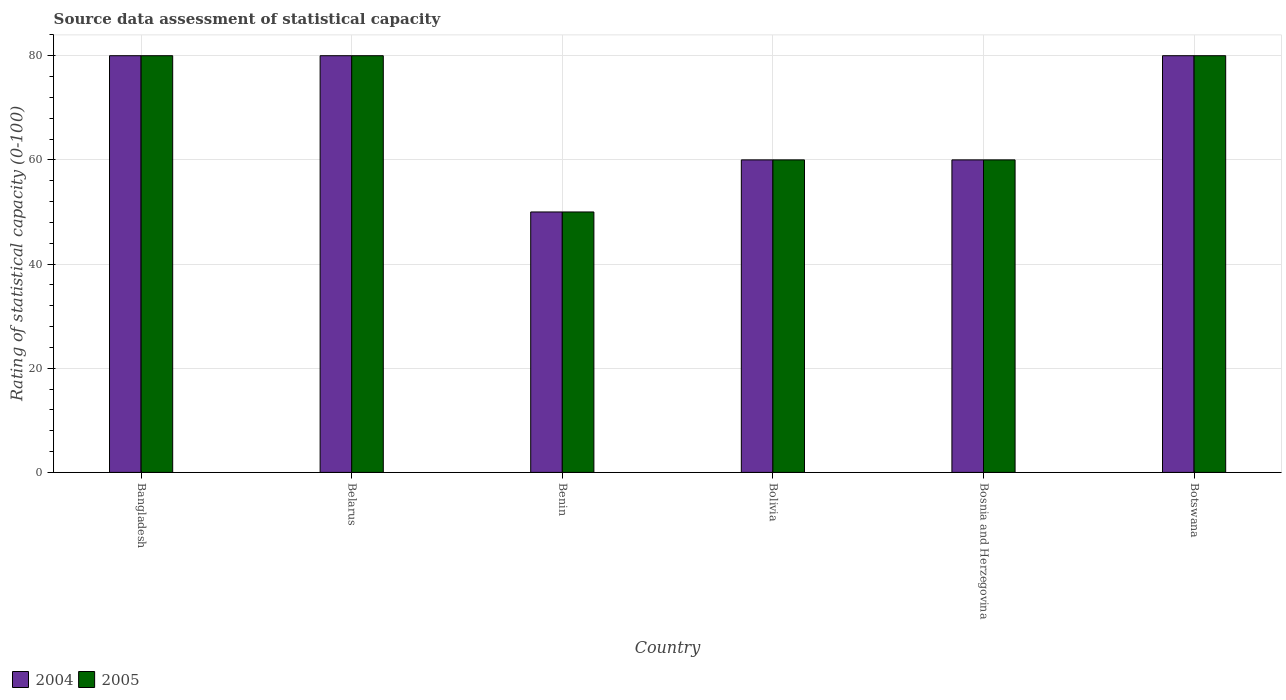How many bars are there on the 1st tick from the right?
Provide a short and direct response. 2. What is the label of the 5th group of bars from the left?
Make the answer very short. Bosnia and Herzegovina. Across all countries, what is the maximum rating of statistical capacity in 2004?
Your answer should be very brief. 80. Across all countries, what is the minimum rating of statistical capacity in 2004?
Keep it short and to the point. 50. In which country was the rating of statistical capacity in 2004 maximum?
Provide a short and direct response. Bangladesh. In which country was the rating of statistical capacity in 2005 minimum?
Offer a very short reply. Benin. What is the total rating of statistical capacity in 2005 in the graph?
Offer a very short reply. 410. What is the average rating of statistical capacity in 2005 per country?
Offer a very short reply. 68.33. What is the ratio of the rating of statistical capacity in 2005 in Bangladesh to that in Bosnia and Herzegovina?
Keep it short and to the point. 1.33. Is the difference between the rating of statistical capacity in 2005 in Benin and Botswana greater than the difference between the rating of statistical capacity in 2004 in Benin and Botswana?
Offer a terse response. No. What is the difference between the highest and the lowest rating of statistical capacity in 2004?
Provide a succinct answer. 30. In how many countries, is the rating of statistical capacity in 2004 greater than the average rating of statistical capacity in 2004 taken over all countries?
Ensure brevity in your answer.  3. Is the sum of the rating of statistical capacity in 2005 in Bangladesh and Benin greater than the maximum rating of statistical capacity in 2004 across all countries?
Offer a terse response. Yes. Are all the bars in the graph horizontal?
Offer a terse response. No. What is the difference between two consecutive major ticks on the Y-axis?
Give a very brief answer. 20. Are the values on the major ticks of Y-axis written in scientific E-notation?
Keep it short and to the point. No. Does the graph contain grids?
Ensure brevity in your answer.  Yes. How many legend labels are there?
Offer a very short reply. 2. What is the title of the graph?
Give a very brief answer. Source data assessment of statistical capacity. Does "2013" appear as one of the legend labels in the graph?
Make the answer very short. No. What is the label or title of the Y-axis?
Give a very brief answer. Rating of statistical capacity (0-100). What is the Rating of statistical capacity (0-100) of 2004 in Bangladesh?
Ensure brevity in your answer.  80. What is the Rating of statistical capacity (0-100) in 2005 in Bangladesh?
Offer a very short reply. 80. What is the Rating of statistical capacity (0-100) in 2004 in Benin?
Your response must be concise. 50. What is the Rating of statistical capacity (0-100) of 2004 in Bolivia?
Offer a terse response. 60. What is the Rating of statistical capacity (0-100) of 2004 in Bosnia and Herzegovina?
Give a very brief answer. 60. What is the Rating of statistical capacity (0-100) of 2005 in Bosnia and Herzegovina?
Give a very brief answer. 60. Across all countries, what is the maximum Rating of statistical capacity (0-100) of 2005?
Offer a very short reply. 80. Across all countries, what is the minimum Rating of statistical capacity (0-100) of 2005?
Offer a very short reply. 50. What is the total Rating of statistical capacity (0-100) in 2004 in the graph?
Your response must be concise. 410. What is the total Rating of statistical capacity (0-100) of 2005 in the graph?
Make the answer very short. 410. What is the difference between the Rating of statistical capacity (0-100) in 2004 in Bangladesh and that in Belarus?
Your answer should be compact. 0. What is the difference between the Rating of statistical capacity (0-100) in 2004 in Bangladesh and that in Benin?
Ensure brevity in your answer.  30. What is the difference between the Rating of statistical capacity (0-100) of 2005 in Bangladesh and that in Benin?
Provide a short and direct response. 30. What is the difference between the Rating of statistical capacity (0-100) in 2004 in Bangladesh and that in Bolivia?
Offer a terse response. 20. What is the difference between the Rating of statistical capacity (0-100) of 2005 in Bangladesh and that in Bolivia?
Give a very brief answer. 20. What is the difference between the Rating of statistical capacity (0-100) of 2004 in Bangladesh and that in Bosnia and Herzegovina?
Your response must be concise. 20. What is the difference between the Rating of statistical capacity (0-100) of 2004 in Bangladesh and that in Botswana?
Your response must be concise. 0. What is the difference between the Rating of statistical capacity (0-100) of 2004 in Belarus and that in Bosnia and Herzegovina?
Ensure brevity in your answer.  20. What is the difference between the Rating of statistical capacity (0-100) in 2005 in Belarus and that in Bosnia and Herzegovina?
Your answer should be very brief. 20. What is the difference between the Rating of statistical capacity (0-100) of 2005 in Benin and that in Bosnia and Herzegovina?
Your answer should be compact. -10. What is the difference between the Rating of statistical capacity (0-100) of 2004 in Benin and that in Botswana?
Provide a succinct answer. -30. What is the difference between the Rating of statistical capacity (0-100) of 2005 in Benin and that in Botswana?
Provide a short and direct response. -30. What is the difference between the Rating of statistical capacity (0-100) in 2004 in Bolivia and that in Bosnia and Herzegovina?
Offer a very short reply. 0. What is the difference between the Rating of statistical capacity (0-100) of 2004 in Bolivia and that in Botswana?
Provide a short and direct response. -20. What is the difference between the Rating of statistical capacity (0-100) of 2004 in Bangladesh and the Rating of statistical capacity (0-100) of 2005 in Belarus?
Your answer should be compact. 0. What is the difference between the Rating of statistical capacity (0-100) of 2004 in Bangladesh and the Rating of statistical capacity (0-100) of 2005 in Bolivia?
Offer a terse response. 20. What is the difference between the Rating of statistical capacity (0-100) in 2004 in Bangladesh and the Rating of statistical capacity (0-100) in 2005 in Bosnia and Herzegovina?
Provide a succinct answer. 20. What is the difference between the Rating of statistical capacity (0-100) in 2004 in Belarus and the Rating of statistical capacity (0-100) in 2005 in Benin?
Give a very brief answer. 30. What is the difference between the Rating of statistical capacity (0-100) in 2004 in Belarus and the Rating of statistical capacity (0-100) in 2005 in Bolivia?
Provide a succinct answer. 20. What is the difference between the Rating of statistical capacity (0-100) of 2004 in Belarus and the Rating of statistical capacity (0-100) of 2005 in Bosnia and Herzegovina?
Ensure brevity in your answer.  20. What is the difference between the Rating of statistical capacity (0-100) of 2004 in Bolivia and the Rating of statistical capacity (0-100) of 2005 in Bosnia and Herzegovina?
Ensure brevity in your answer.  0. What is the difference between the Rating of statistical capacity (0-100) in 2004 in Bolivia and the Rating of statistical capacity (0-100) in 2005 in Botswana?
Provide a short and direct response. -20. What is the average Rating of statistical capacity (0-100) in 2004 per country?
Make the answer very short. 68.33. What is the average Rating of statistical capacity (0-100) in 2005 per country?
Your response must be concise. 68.33. What is the difference between the Rating of statistical capacity (0-100) of 2004 and Rating of statistical capacity (0-100) of 2005 in Bolivia?
Provide a succinct answer. 0. What is the difference between the Rating of statistical capacity (0-100) of 2004 and Rating of statistical capacity (0-100) of 2005 in Bosnia and Herzegovina?
Your response must be concise. 0. What is the ratio of the Rating of statistical capacity (0-100) in 2004 in Bangladesh to that in Bolivia?
Ensure brevity in your answer.  1.33. What is the ratio of the Rating of statistical capacity (0-100) of 2005 in Bangladesh to that in Botswana?
Provide a succinct answer. 1. What is the ratio of the Rating of statistical capacity (0-100) in 2005 in Belarus to that in Benin?
Your answer should be very brief. 1.6. What is the ratio of the Rating of statistical capacity (0-100) of 2004 in Belarus to that in Bolivia?
Ensure brevity in your answer.  1.33. What is the ratio of the Rating of statistical capacity (0-100) in 2005 in Belarus to that in Bosnia and Herzegovina?
Your response must be concise. 1.33. What is the ratio of the Rating of statistical capacity (0-100) of 2005 in Benin to that in Bolivia?
Your response must be concise. 0.83. What is the ratio of the Rating of statistical capacity (0-100) of 2005 in Benin to that in Bosnia and Herzegovina?
Offer a terse response. 0.83. What is the ratio of the Rating of statistical capacity (0-100) in 2005 in Benin to that in Botswana?
Offer a terse response. 0.62. What is the ratio of the Rating of statistical capacity (0-100) in 2004 in Bosnia and Herzegovina to that in Botswana?
Your response must be concise. 0.75. What is the difference between the highest and the second highest Rating of statistical capacity (0-100) of 2005?
Ensure brevity in your answer.  0. 